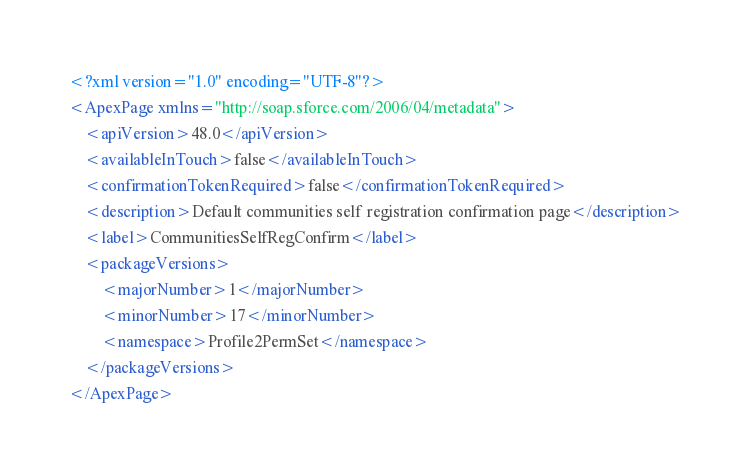Convert code to text. <code><loc_0><loc_0><loc_500><loc_500><_XML_><?xml version="1.0" encoding="UTF-8"?>
<ApexPage xmlns="http://soap.sforce.com/2006/04/metadata">
    <apiVersion>48.0</apiVersion>
    <availableInTouch>false</availableInTouch>
    <confirmationTokenRequired>false</confirmationTokenRequired>
    <description>Default communities self registration confirmation page</description>
    <label>CommunitiesSelfRegConfirm</label>
    <packageVersions>
        <majorNumber>1</majorNumber>
        <minorNumber>17</minorNumber>
        <namespace>Profile2PermSet</namespace>
    </packageVersions>
</ApexPage>
</code> 